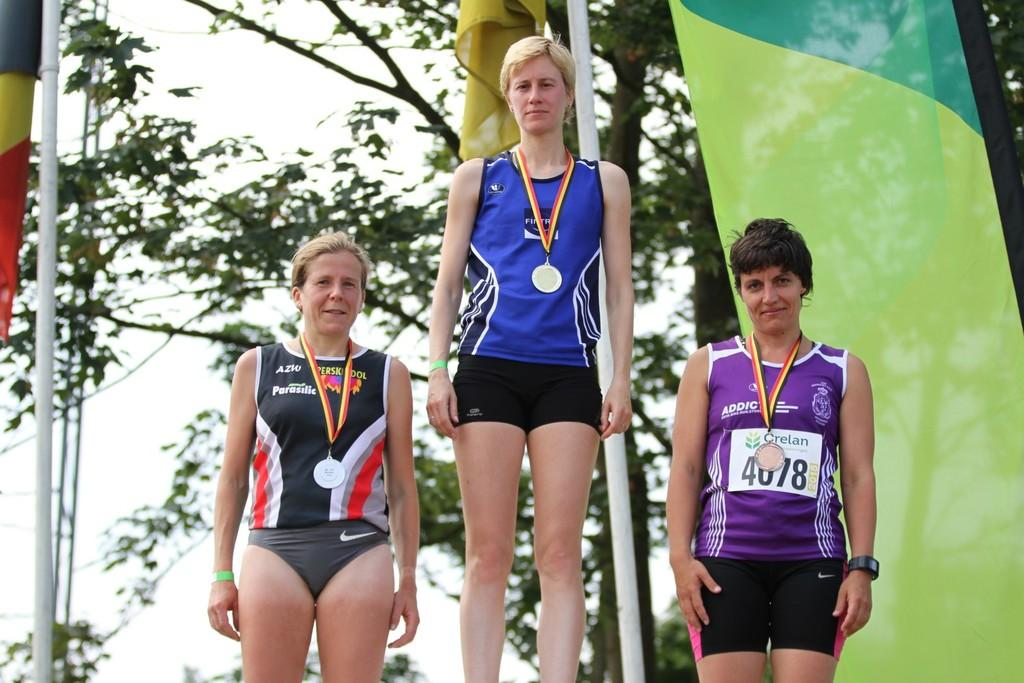<image>
Write a terse but informative summary of the picture. A woman in a black shirt that says Parasilic on the front stands to the left of two other women. 